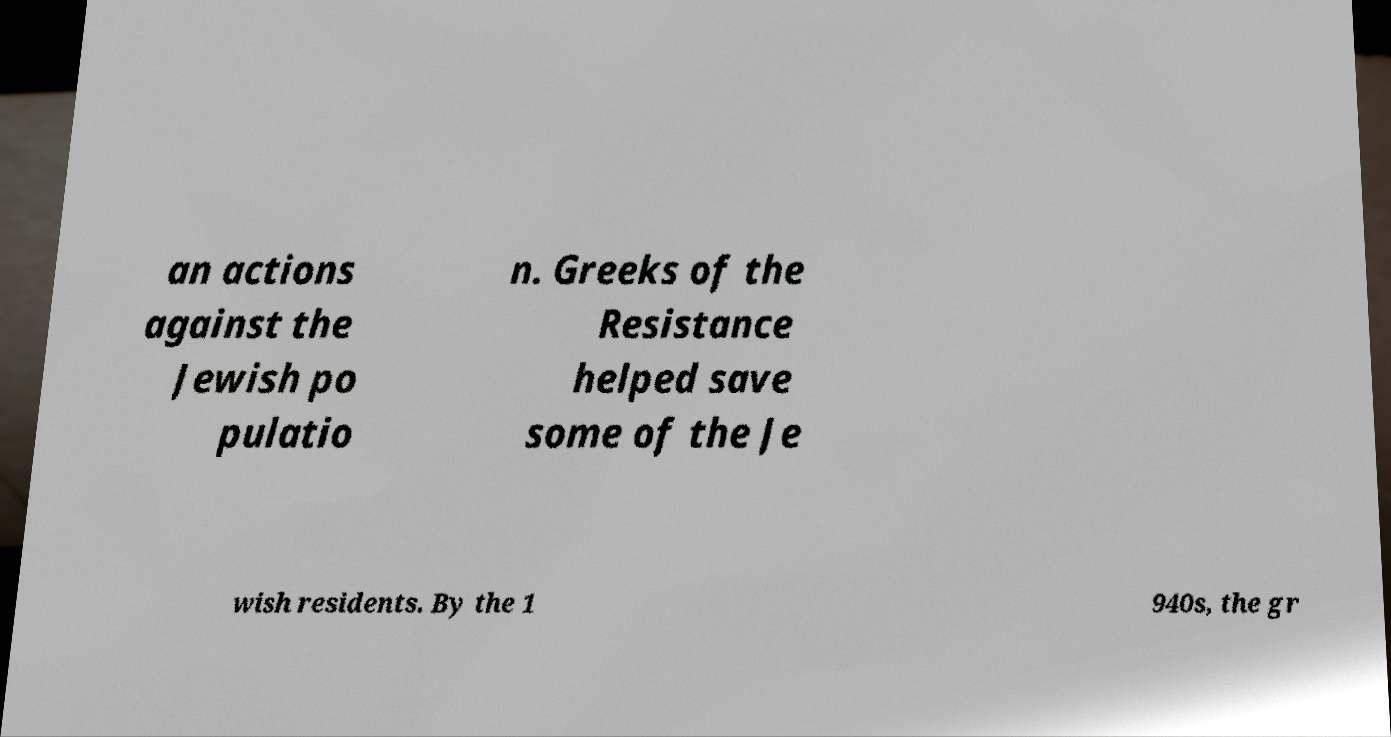Please read and relay the text visible in this image. What does it say? an actions against the Jewish po pulatio n. Greeks of the Resistance helped save some of the Je wish residents. By the 1 940s, the gr 